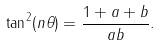Convert formula to latex. <formula><loc_0><loc_0><loc_500><loc_500>\tan ^ { 2 } ( n \theta ) = \frac { 1 + a + b } { a b } .</formula> 